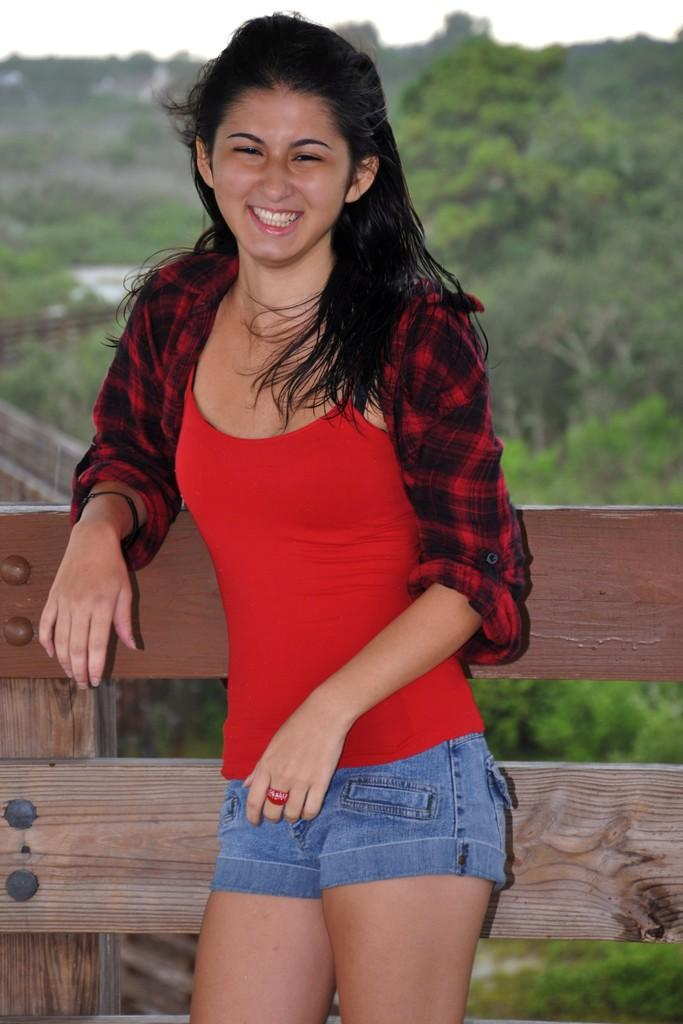What is the main subject of the image? There is a woman standing in the center of the image. What is the woman doing in the image? The woman is smiling. What type of barrier can be seen in the image? There is a wooden fence in the image. What can be seen in the background of the image? There are trees and the sky visible in the background of the image. How many cords are attached to the woman's hand in the image? There are no cords attached to the woman's hand in the image. What type of number is written on the woman's shirt in the image? There is no number visible on the woman's shirt in the image. 